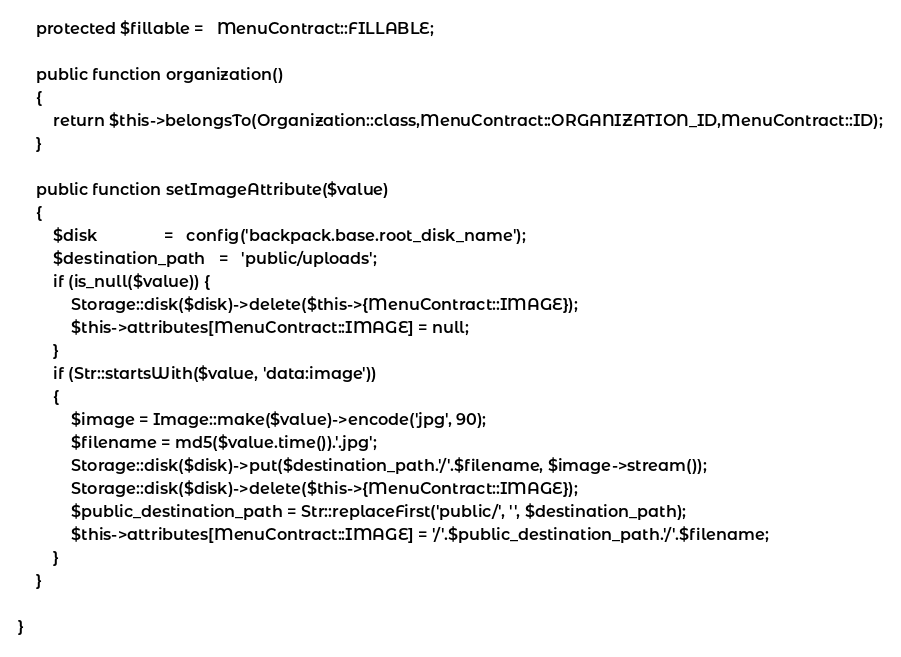<code> <loc_0><loc_0><loc_500><loc_500><_PHP_>    protected $fillable =   MenuContract::FILLABLE;

    public function organization()
    {
        return $this->belongsTo(Organization::class,MenuContract::ORGANIZATION_ID,MenuContract::ID);
    }

    public function setImageAttribute($value)
    {
        $disk               =   config('backpack.base.root_disk_name');
        $destination_path   =   'public/uploads';
        if (is_null($value)) {
            Storage::disk($disk)->delete($this->{MenuContract::IMAGE});
            $this->attributes[MenuContract::IMAGE] = null;
        }
        if (Str::startsWith($value, 'data:image'))
        {
            $image = Image::make($value)->encode('jpg', 90);
            $filename = md5($value.time()).'.jpg';
            Storage::disk($disk)->put($destination_path.'/'.$filename, $image->stream());
            Storage::disk($disk)->delete($this->{MenuContract::IMAGE});
            $public_destination_path = Str::replaceFirst('public/', '', $destination_path);
            $this->attributes[MenuContract::IMAGE] = '/'.$public_destination_path.'/'.$filename;
        }
    }

}
</code> 